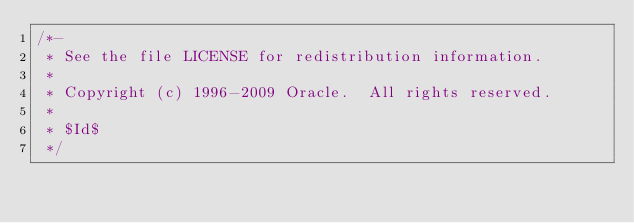<code> <loc_0><loc_0><loc_500><loc_500><_C_>/*-
 * See the file LICENSE for redistribution information.
 *
 * Copyright (c) 1996-2009 Oracle.  All rights reserved.
 *
 * $Id$
 */
</code> 